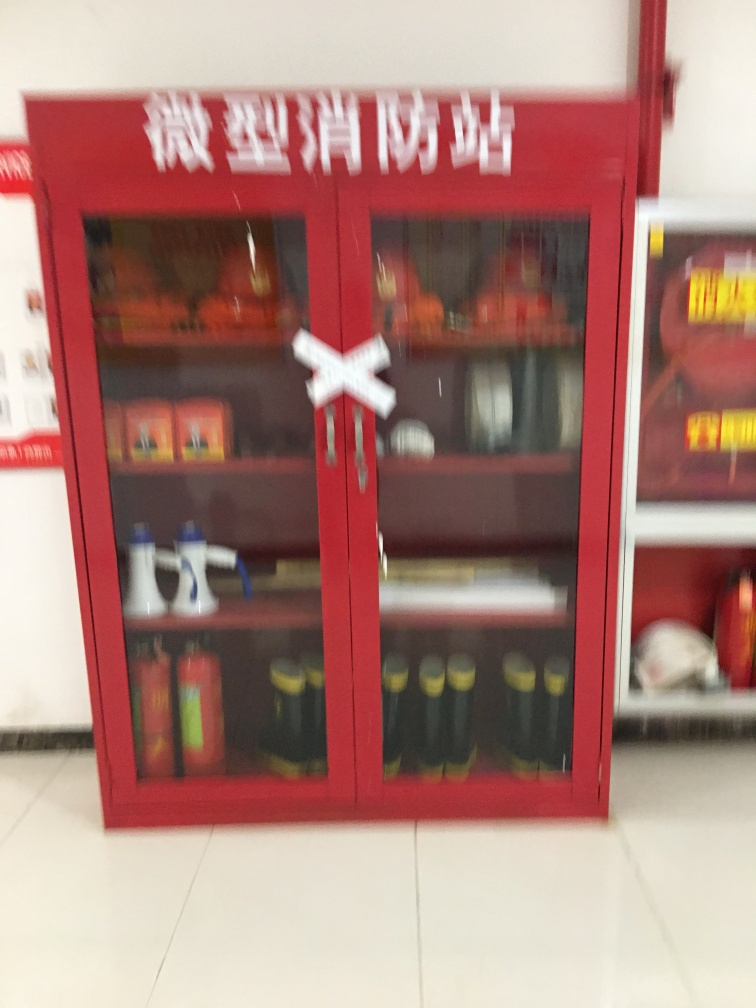Can you suggest ways to improve the clarity of such images in the future? Improving image clarity can be achieved through several means: using a camera with a higher resolution, ensuring adequate lighting when taking the photo, holding the camera steady to prevent motion blur, and using the camera's focus feature to sharpen the subject. For critical purposes such as documenting emergency equipment, taking multiple shots from various angles can also be useful. 